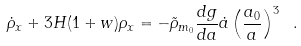<formula> <loc_0><loc_0><loc_500><loc_500>\dot { \rho } _ { x } + 3 H ( 1 + w ) \rho _ { x } = - \tilde { \rho } _ { m _ { 0 } } \frac { d g } { d a } \dot { a } \left ( \frac { a _ { 0 } } { a } \right ) ^ { 3 } \ .</formula> 